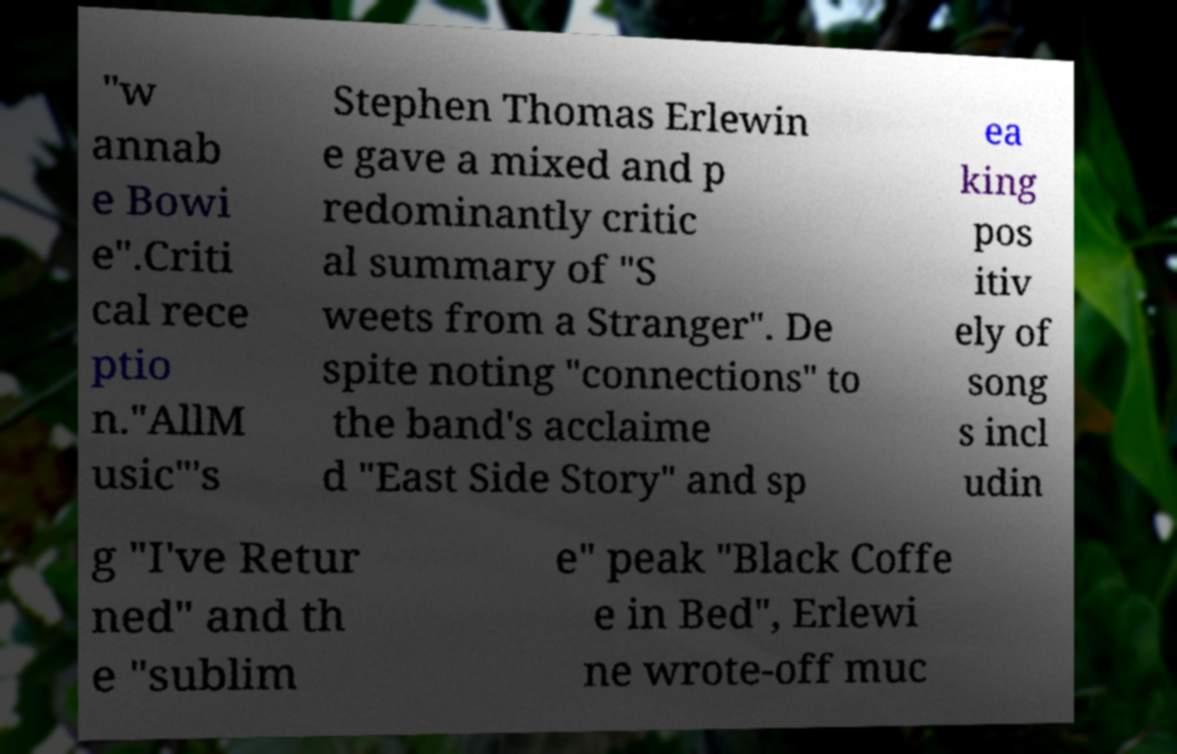For documentation purposes, I need the text within this image transcribed. Could you provide that? "w annab e Bowi e".Criti cal rece ptio n."AllM usic"'s Stephen Thomas Erlewin e gave a mixed and p redominantly critic al summary of "S weets from a Stranger". De spite noting "connections" to the band's acclaime d "East Side Story" and sp ea king pos itiv ely of song s incl udin g "I've Retur ned" and th e "sublim e" peak "Black Coffe e in Bed", Erlewi ne wrote-off muc 